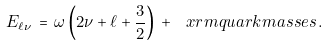Convert formula to latex. <formula><loc_0><loc_0><loc_500><loc_500>E _ { \ell \nu } \, = \, \omega \left ( 2 \nu + \ell + \frac { 3 } { 2 } \right ) \, + \, \ x r m { q u a r k m a s s e s } \, .</formula> 